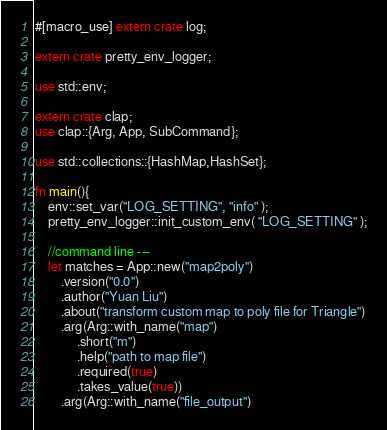Convert code to text. <code><loc_0><loc_0><loc_500><loc_500><_Rust_>#[macro_use] extern crate log;

extern crate pretty_env_logger;

use std::env;

extern crate clap;
use clap::{Arg, App, SubCommand};

use std::collections::{HashMap,HashSet};

fn main(){
    env::set_var("LOG_SETTING", "info" );
    pretty_env_logger::init_custom_env( "LOG_SETTING" );

    //command line ---
    let matches = App::new("map2poly")
        .version("0.0")
        .author("Yuan Liu")
        .about("transform custom map to poly file for Triangle")
        .arg(Arg::with_name("map")
             .short("m")
             .help("path to map file")
             .required(true)
             .takes_value(true))
        .arg(Arg::with_name("file_output")</code> 